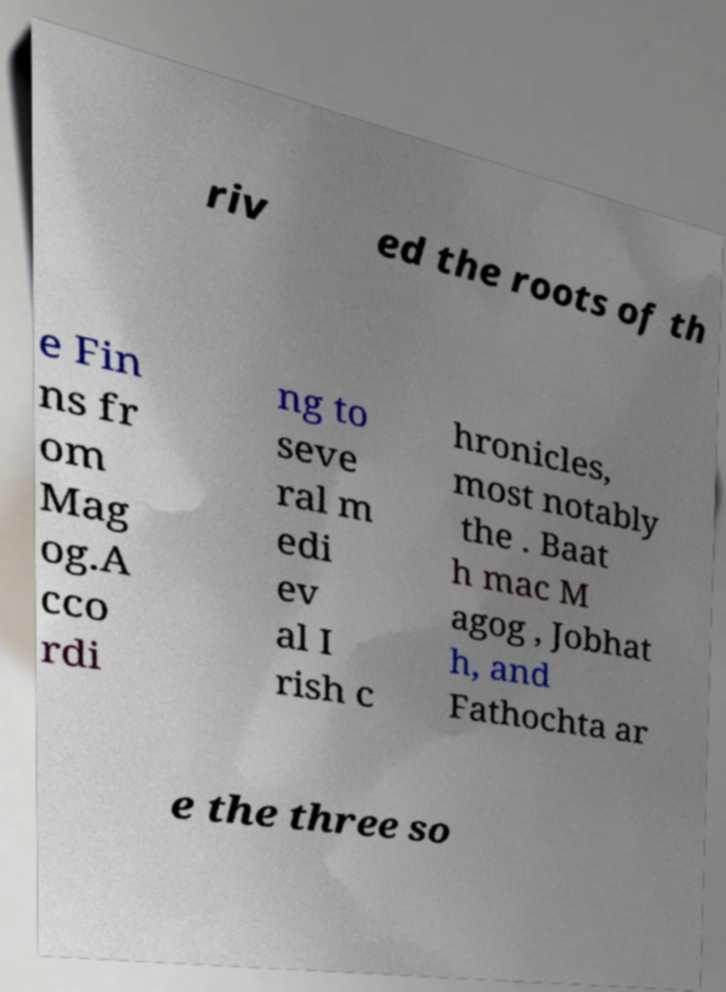Can you read and provide the text displayed in the image?This photo seems to have some interesting text. Can you extract and type it out for me? riv ed the roots of th e Fin ns fr om Mag og.A cco rdi ng to seve ral m edi ev al I rish c hronicles, most notably the . Baat h mac M agog , Jobhat h, and Fathochta ar e the three so 